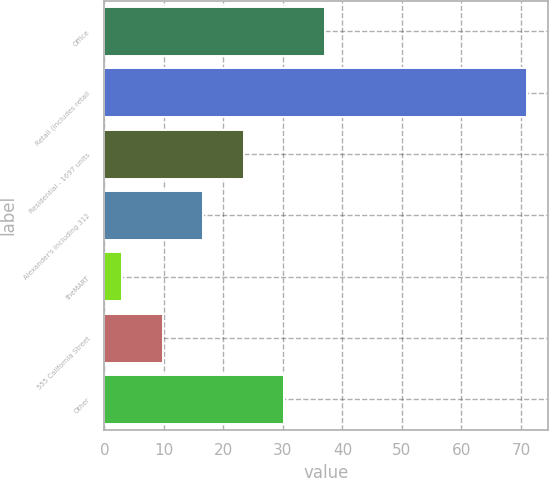Convert chart. <chart><loc_0><loc_0><loc_500><loc_500><bar_chart><fcel>Office<fcel>Retail (includes retail<fcel>Residential - 1697 units<fcel>Alexander's including 312<fcel>theMART<fcel>555 California Street<fcel>Other<nl><fcel>37<fcel>71<fcel>23.4<fcel>16.6<fcel>3<fcel>9.8<fcel>30.2<nl></chart> 